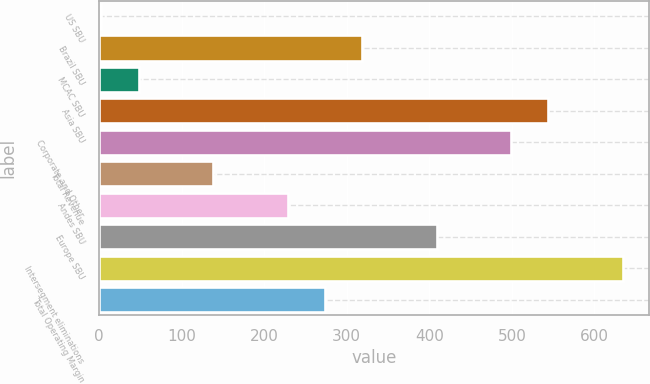<chart> <loc_0><loc_0><loc_500><loc_500><bar_chart><fcel>US SBU<fcel>Brazil SBU<fcel>MCAC SBU<fcel>Asia SBU<fcel>Corporate and Other<fcel>Total Revenue<fcel>Andes SBU<fcel>Europe SBU<fcel>Intersegment eliminations<fcel>Total Operating Margin<nl><fcel>3<fcel>318.7<fcel>48.1<fcel>544.2<fcel>499.1<fcel>138.3<fcel>228.5<fcel>408.9<fcel>634.4<fcel>273.6<nl></chart> 